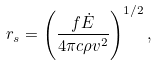Convert formula to latex. <formula><loc_0><loc_0><loc_500><loc_500>r _ { s } = \left ( \frac { f \dot { E } } { 4 \pi c \rho v ^ { 2 } } \right ) ^ { 1 / 2 } ,</formula> 